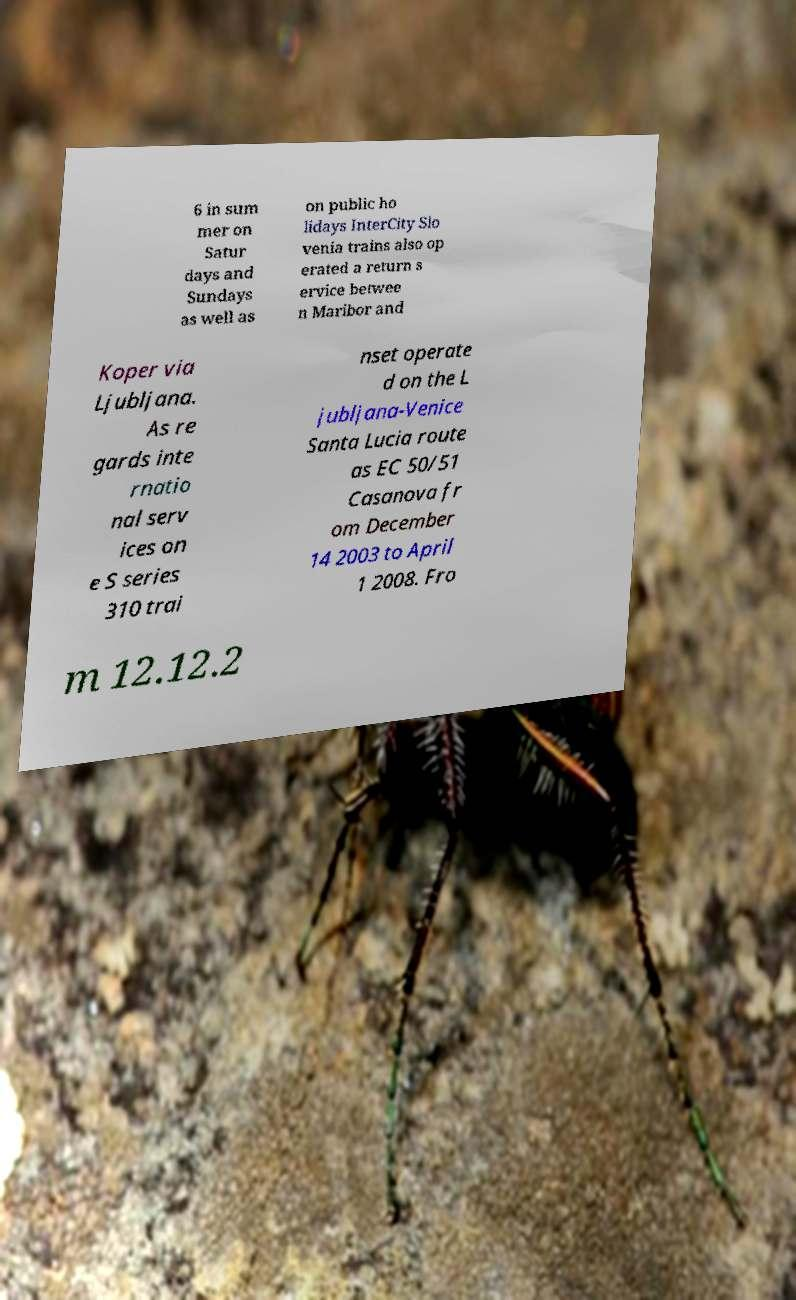What messages or text are displayed in this image? I need them in a readable, typed format. 6 in sum mer on Satur days and Sundays as well as on public ho lidays InterCity Slo venia trains also op erated a return s ervice betwee n Maribor and Koper via Ljubljana. As re gards inte rnatio nal serv ices on e S series 310 trai nset operate d on the L jubljana-Venice Santa Lucia route as EC 50/51 Casanova fr om December 14 2003 to April 1 2008. Fro m 12.12.2 